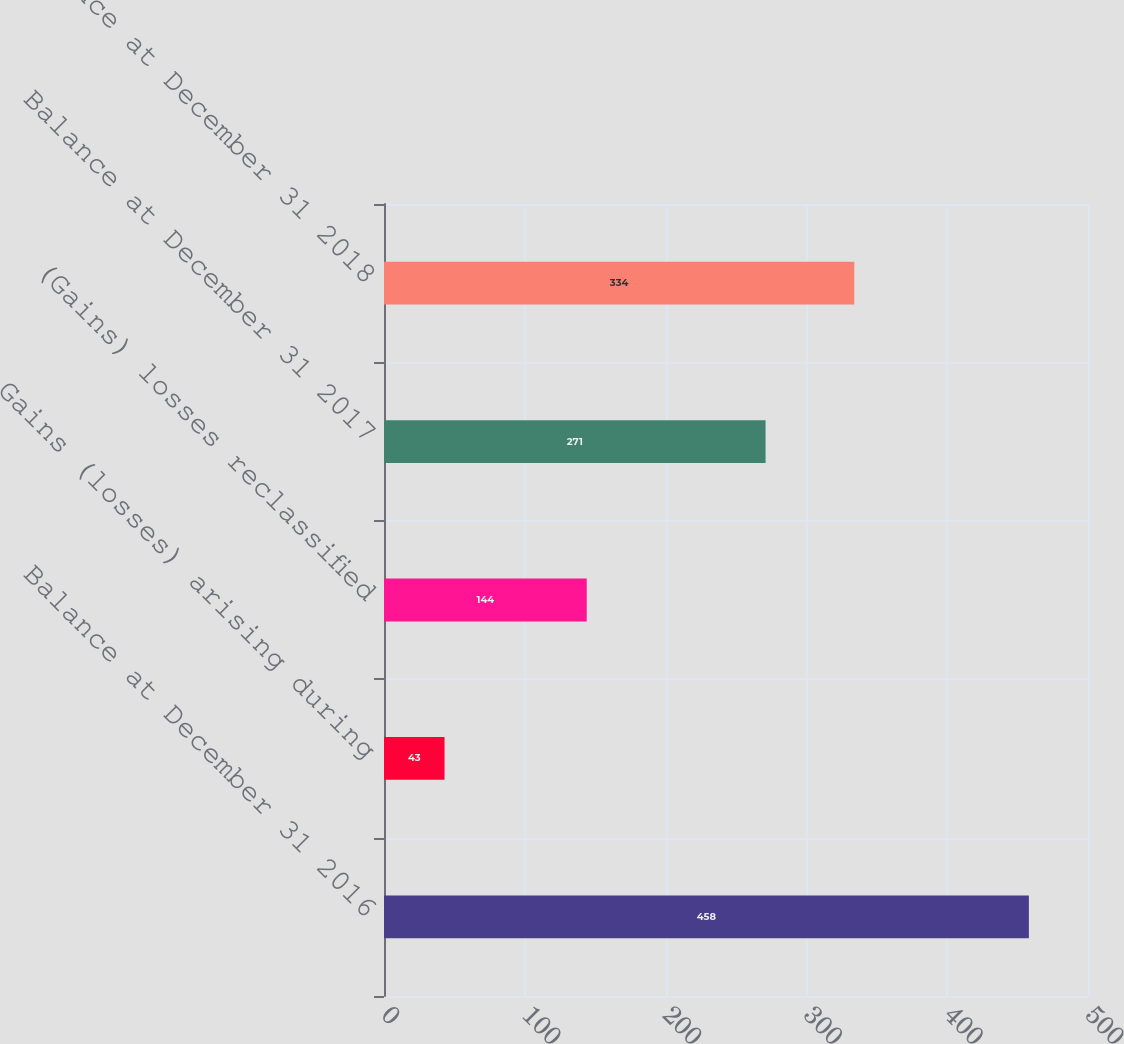<chart> <loc_0><loc_0><loc_500><loc_500><bar_chart><fcel>Balance at December 31 2016<fcel>Gains (losses) arising during<fcel>(Gains) losses reclassified<fcel>Balance at December 31 2017<fcel>Balance at December 31 2018<nl><fcel>458<fcel>43<fcel>144<fcel>271<fcel>334<nl></chart> 